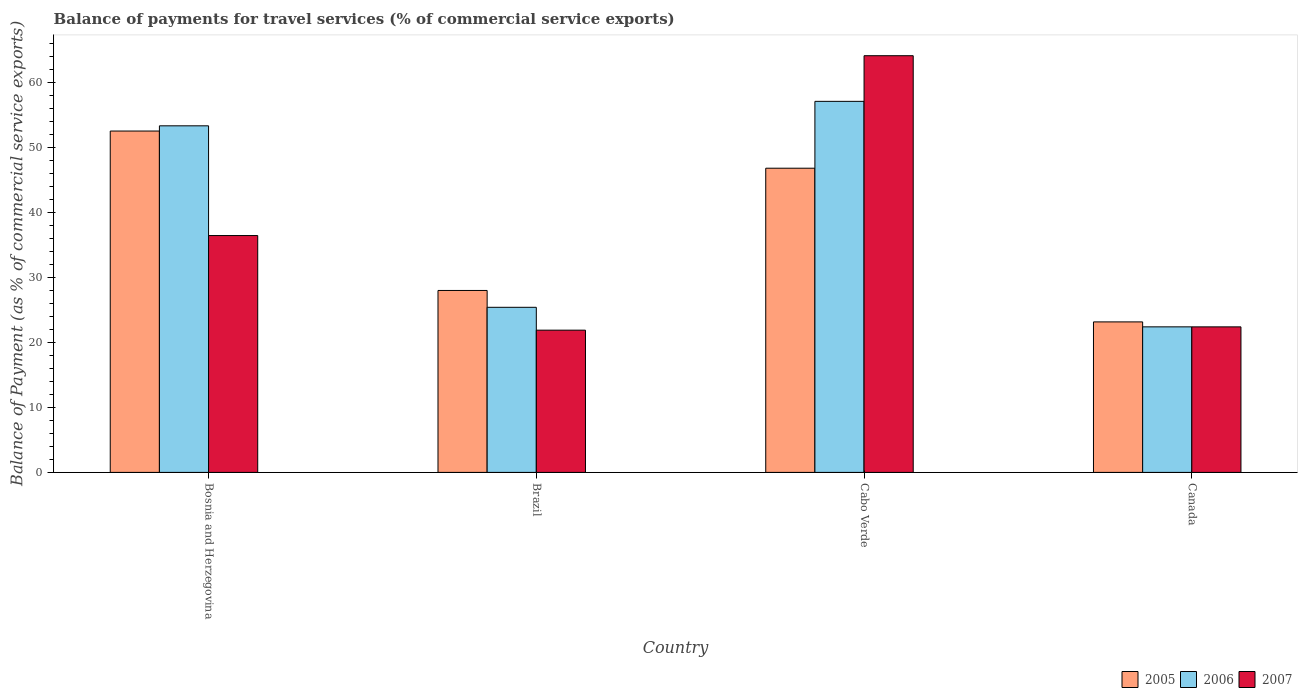How many groups of bars are there?
Offer a terse response. 4. Are the number of bars per tick equal to the number of legend labels?
Ensure brevity in your answer.  Yes. How many bars are there on the 1st tick from the left?
Keep it short and to the point. 3. What is the label of the 1st group of bars from the left?
Your answer should be compact. Bosnia and Herzegovina. In how many cases, is the number of bars for a given country not equal to the number of legend labels?
Ensure brevity in your answer.  0. What is the balance of payments for travel services in 2006 in Bosnia and Herzegovina?
Ensure brevity in your answer.  53.36. Across all countries, what is the maximum balance of payments for travel services in 2007?
Keep it short and to the point. 64.16. Across all countries, what is the minimum balance of payments for travel services in 2005?
Offer a very short reply. 23.17. In which country was the balance of payments for travel services in 2005 maximum?
Give a very brief answer. Bosnia and Herzegovina. What is the total balance of payments for travel services in 2007 in the graph?
Provide a short and direct response. 144.94. What is the difference between the balance of payments for travel services in 2007 in Cabo Verde and that in Canada?
Keep it short and to the point. 41.75. What is the difference between the balance of payments for travel services in 2007 in Bosnia and Herzegovina and the balance of payments for travel services in 2005 in Brazil?
Your answer should be compact. 8.45. What is the average balance of payments for travel services in 2007 per country?
Your answer should be very brief. 36.23. What is the difference between the balance of payments for travel services of/in 2006 and balance of payments for travel services of/in 2005 in Bosnia and Herzegovina?
Your answer should be compact. 0.8. What is the ratio of the balance of payments for travel services in 2006 in Cabo Verde to that in Canada?
Make the answer very short. 2.55. Is the difference between the balance of payments for travel services in 2006 in Bosnia and Herzegovina and Brazil greater than the difference between the balance of payments for travel services in 2005 in Bosnia and Herzegovina and Brazil?
Provide a short and direct response. Yes. What is the difference between the highest and the second highest balance of payments for travel services in 2005?
Keep it short and to the point. 24.55. What is the difference between the highest and the lowest balance of payments for travel services in 2005?
Provide a succinct answer. 29.39. Is the sum of the balance of payments for travel services in 2005 in Cabo Verde and Canada greater than the maximum balance of payments for travel services in 2006 across all countries?
Provide a succinct answer. Yes. What does the 1st bar from the left in Canada represents?
Provide a short and direct response. 2005. How many bars are there?
Your answer should be very brief. 12. Are all the bars in the graph horizontal?
Make the answer very short. No. What is the difference between two consecutive major ticks on the Y-axis?
Ensure brevity in your answer.  10. Does the graph contain grids?
Provide a short and direct response. No. How are the legend labels stacked?
Provide a short and direct response. Horizontal. What is the title of the graph?
Your response must be concise. Balance of payments for travel services (% of commercial service exports). Does "1990" appear as one of the legend labels in the graph?
Offer a terse response. No. What is the label or title of the X-axis?
Your answer should be compact. Country. What is the label or title of the Y-axis?
Provide a short and direct response. Balance of Payment (as % of commercial service exports). What is the Balance of Payment (as % of commercial service exports) in 2005 in Bosnia and Herzegovina?
Ensure brevity in your answer.  52.56. What is the Balance of Payment (as % of commercial service exports) of 2006 in Bosnia and Herzegovina?
Give a very brief answer. 53.36. What is the Balance of Payment (as % of commercial service exports) of 2007 in Bosnia and Herzegovina?
Provide a succinct answer. 36.47. What is the Balance of Payment (as % of commercial service exports) of 2005 in Brazil?
Your response must be concise. 28.01. What is the Balance of Payment (as % of commercial service exports) of 2006 in Brazil?
Your answer should be compact. 25.42. What is the Balance of Payment (as % of commercial service exports) in 2007 in Brazil?
Your answer should be compact. 21.9. What is the Balance of Payment (as % of commercial service exports) of 2005 in Cabo Verde?
Your answer should be very brief. 46.84. What is the Balance of Payment (as % of commercial service exports) in 2006 in Cabo Verde?
Ensure brevity in your answer.  57.13. What is the Balance of Payment (as % of commercial service exports) in 2007 in Cabo Verde?
Provide a succinct answer. 64.16. What is the Balance of Payment (as % of commercial service exports) in 2005 in Canada?
Make the answer very short. 23.17. What is the Balance of Payment (as % of commercial service exports) in 2006 in Canada?
Give a very brief answer. 22.41. What is the Balance of Payment (as % of commercial service exports) in 2007 in Canada?
Make the answer very short. 22.41. Across all countries, what is the maximum Balance of Payment (as % of commercial service exports) in 2005?
Make the answer very short. 52.56. Across all countries, what is the maximum Balance of Payment (as % of commercial service exports) in 2006?
Give a very brief answer. 57.13. Across all countries, what is the maximum Balance of Payment (as % of commercial service exports) in 2007?
Provide a succinct answer. 64.16. Across all countries, what is the minimum Balance of Payment (as % of commercial service exports) of 2005?
Offer a terse response. 23.17. Across all countries, what is the minimum Balance of Payment (as % of commercial service exports) in 2006?
Your answer should be compact. 22.41. Across all countries, what is the minimum Balance of Payment (as % of commercial service exports) in 2007?
Provide a succinct answer. 21.9. What is the total Balance of Payment (as % of commercial service exports) of 2005 in the graph?
Provide a succinct answer. 150.59. What is the total Balance of Payment (as % of commercial service exports) of 2006 in the graph?
Your answer should be very brief. 158.33. What is the total Balance of Payment (as % of commercial service exports) in 2007 in the graph?
Your answer should be very brief. 144.94. What is the difference between the Balance of Payment (as % of commercial service exports) in 2005 in Bosnia and Herzegovina and that in Brazil?
Make the answer very short. 24.55. What is the difference between the Balance of Payment (as % of commercial service exports) in 2006 in Bosnia and Herzegovina and that in Brazil?
Give a very brief answer. 27.94. What is the difference between the Balance of Payment (as % of commercial service exports) in 2007 in Bosnia and Herzegovina and that in Brazil?
Give a very brief answer. 14.57. What is the difference between the Balance of Payment (as % of commercial service exports) of 2005 in Bosnia and Herzegovina and that in Cabo Verde?
Make the answer very short. 5.72. What is the difference between the Balance of Payment (as % of commercial service exports) in 2006 in Bosnia and Herzegovina and that in Cabo Verde?
Provide a short and direct response. -3.77. What is the difference between the Balance of Payment (as % of commercial service exports) of 2007 in Bosnia and Herzegovina and that in Cabo Verde?
Ensure brevity in your answer.  -27.69. What is the difference between the Balance of Payment (as % of commercial service exports) of 2005 in Bosnia and Herzegovina and that in Canada?
Provide a short and direct response. 29.39. What is the difference between the Balance of Payment (as % of commercial service exports) of 2006 in Bosnia and Herzegovina and that in Canada?
Offer a terse response. 30.95. What is the difference between the Balance of Payment (as % of commercial service exports) of 2007 in Bosnia and Herzegovina and that in Canada?
Offer a very short reply. 14.06. What is the difference between the Balance of Payment (as % of commercial service exports) in 2005 in Brazil and that in Cabo Verde?
Make the answer very short. -18.82. What is the difference between the Balance of Payment (as % of commercial service exports) in 2006 in Brazil and that in Cabo Verde?
Give a very brief answer. -31.71. What is the difference between the Balance of Payment (as % of commercial service exports) in 2007 in Brazil and that in Cabo Verde?
Provide a succinct answer. -42.26. What is the difference between the Balance of Payment (as % of commercial service exports) of 2005 in Brazil and that in Canada?
Your answer should be very brief. 4.84. What is the difference between the Balance of Payment (as % of commercial service exports) of 2006 in Brazil and that in Canada?
Your answer should be very brief. 3.01. What is the difference between the Balance of Payment (as % of commercial service exports) in 2007 in Brazil and that in Canada?
Keep it short and to the point. -0.51. What is the difference between the Balance of Payment (as % of commercial service exports) in 2005 in Cabo Verde and that in Canada?
Keep it short and to the point. 23.66. What is the difference between the Balance of Payment (as % of commercial service exports) in 2006 in Cabo Verde and that in Canada?
Keep it short and to the point. 34.72. What is the difference between the Balance of Payment (as % of commercial service exports) of 2007 in Cabo Verde and that in Canada?
Provide a short and direct response. 41.75. What is the difference between the Balance of Payment (as % of commercial service exports) of 2005 in Bosnia and Herzegovina and the Balance of Payment (as % of commercial service exports) of 2006 in Brazil?
Provide a short and direct response. 27.14. What is the difference between the Balance of Payment (as % of commercial service exports) of 2005 in Bosnia and Herzegovina and the Balance of Payment (as % of commercial service exports) of 2007 in Brazil?
Offer a terse response. 30.66. What is the difference between the Balance of Payment (as % of commercial service exports) in 2006 in Bosnia and Herzegovina and the Balance of Payment (as % of commercial service exports) in 2007 in Brazil?
Give a very brief answer. 31.46. What is the difference between the Balance of Payment (as % of commercial service exports) in 2005 in Bosnia and Herzegovina and the Balance of Payment (as % of commercial service exports) in 2006 in Cabo Verde?
Give a very brief answer. -4.57. What is the difference between the Balance of Payment (as % of commercial service exports) in 2005 in Bosnia and Herzegovina and the Balance of Payment (as % of commercial service exports) in 2007 in Cabo Verde?
Give a very brief answer. -11.6. What is the difference between the Balance of Payment (as % of commercial service exports) of 2006 in Bosnia and Herzegovina and the Balance of Payment (as % of commercial service exports) of 2007 in Cabo Verde?
Ensure brevity in your answer.  -10.8. What is the difference between the Balance of Payment (as % of commercial service exports) of 2005 in Bosnia and Herzegovina and the Balance of Payment (as % of commercial service exports) of 2006 in Canada?
Keep it short and to the point. 30.15. What is the difference between the Balance of Payment (as % of commercial service exports) in 2005 in Bosnia and Herzegovina and the Balance of Payment (as % of commercial service exports) in 2007 in Canada?
Offer a terse response. 30.15. What is the difference between the Balance of Payment (as % of commercial service exports) of 2006 in Bosnia and Herzegovina and the Balance of Payment (as % of commercial service exports) of 2007 in Canada?
Provide a succinct answer. 30.96. What is the difference between the Balance of Payment (as % of commercial service exports) in 2005 in Brazil and the Balance of Payment (as % of commercial service exports) in 2006 in Cabo Verde?
Offer a terse response. -29.12. What is the difference between the Balance of Payment (as % of commercial service exports) in 2005 in Brazil and the Balance of Payment (as % of commercial service exports) in 2007 in Cabo Verde?
Your answer should be very brief. -36.15. What is the difference between the Balance of Payment (as % of commercial service exports) in 2006 in Brazil and the Balance of Payment (as % of commercial service exports) in 2007 in Cabo Verde?
Your answer should be very brief. -38.74. What is the difference between the Balance of Payment (as % of commercial service exports) in 2005 in Brazil and the Balance of Payment (as % of commercial service exports) in 2006 in Canada?
Give a very brief answer. 5.6. What is the difference between the Balance of Payment (as % of commercial service exports) of 2005 in Brazil and the Balance of Payment (as % of commercial service exports) of 2007 in Canada?
Your answer should be very brief. 5.61. What is the difference between the Balance of Payment (as % of commercial service exports) in 2006 in Brazil and the Balance of Payment (as % of commercial service exports) in 2007 in Canada?
Your answer should be compact. 3.01. What is the difference between the Balance of Payment (as % of commercial service exports) in 2005 in Cabo Verde and the Balance of Payment (as % of commercial service exports) in 2006 in Canada?
Offer a very short reply. 24.43. What is the difference between the Balance of Payment (as % of commercial service exports) in 2005 in Cabo Verde and the Balance of Payment (as % of commercial service exports) in 2007 in Canada?
Give a very brief answer. 24.43. What is the difference between the Balance of Payment (as % of commercial service exports) in 2006 in Cabo Verde and the Balance of Payment (as % of commercial service exports) in 2007 in Canada?
Offer a terse response. 34.72. What is the average Balance of Payment (as % of commercial service exports) in 2005 per country?
Provide a short and direct response. 37.65. What is the average Balance of Payment (as % of commercial service exports) of 2006 per country?
Give a very brief answer. 39.58. What is the average Balance of Payment (as % of commercial service exports) of 2007 per country?
Provide a succinct answer. 36.23. What is the difference between the Balance of Payment (as % of commercial service exports) in 2005 and Balance of Payment (as % of commercial service exports) in 2006 in Bosnia and Herzegovina?
Provide a short and direct response. -0.8. What is the difference between the Balance of Payment (as % of commercial service exports) in 2005 and Balance of Payment (as % of commercial service exports) in 2007 in Bosnia and Herzegovina?
Your response must be concise. 16.09. What is the difference between the Balance of Payment (as % of commercial service exports) in 2006 and Balance of Payment (as % of commercial service exports) in 2007 in Bosnia and Herzegovina?
Give a very brief answer. 16.9. What is the difference between the Balance of Payment (as % of commercial service exports) in 2005 and Balance of Payment (as % of commercial service exports) in 2006 in Brazil?
Give a very brief answer. 2.59. What is the difference between the Balance of Payment (as % of commercial service exports) in 2005 and Balance of Payment (as % of commercial service exports) in 2007 in Brazil?
Offer a very short reply. 6.11. What is the difference between the Balance of Payment (as % of commercial service exports) in 2006 and Balance of Payment (as % of commercial service exports) in 2007 in Brazil?
Make the answer very short. 3.52. What is the difference between the Balance of Payment (as % of commercial service exports) of 2005 and Balance of Payment (as % of commercial service exports) of 2006 in Cabo Verde?
Keep it short and to the point. -10.29. What is the difference between the Balance of Payment (as % of commercial service exports) of 2005 and Balance of Payment (as % of commercial service exports) of 2007 in Cabo Verde?
Your answer should be compact. -17.32. What is the difference between the Balance of Payment (as % of commercial service exports) of 2006 and Balance of Payment (as % of commercial service exports) of 2007 in Cabo Verde?
Provide a succinct answer. -7.03. What is the difference between the Balance of Payment (as % of commercial service exports) of 2005 and Balance of Payment (as % of commercial service exports) of 2006 in Canada?
Your response must be concise. 0.76. What is the difference between the Balance of Payment (as % of commercial service exports) in 2005 and Balance of Payment (as % of commercial service exports) in 2007 in Canada?
Make the answer very short. 0.77. What is the difference between the Balance of Payment (as % of commercial service exports) of 2006 and Balance of Payment (as % of commercial service exports) of 2007 in Canada?
Offer a terse response. 0. What is the ratio of the Balance of Payment (as % of commercial service exports) of 2005 in Bosnia and Herzegovina to that in Brazil?
Give a very brief answer. 1.88. What is the ratio of the Balance of Payment (as % of commercial service exports) in 2006 in Bosnia and Herzegovina to that in Brazil?
Give a very brief answer. 2.1. What is the ratio of the Balance of Payment (as % of commercial service exports) of 2007 in Bosnia and Herzegovina to that in Brazil?
Provide a succinct answer. 1.67. What is the ratio of the Balance of Payment (as % of commercial service exports) in 2005 in Bosnia and Herzegovina to that in Cabo Verde?
Your answer should be very brief. 1.12. What is the ratio of the Balance of Payment (as % of commercial service exports) of 2006 in Bosnia and Herzegovina to that in Cabo Verde?
Ensure brevity in your answer.  0.93. What is the ratio of the Balance of Payment (as % of commercial service exports) in 2007 in Bosnia and Herzegovina to that in Cabo Verde?
Keep it short and to the point. 0.57. What is the ratio of the Balance of Payment (as % of commercial service exports) in 2005 in Bosnia and Herzegovina to that in Canada?
Offer a very short reply. 2.27. What is the ratio of the Balance of Payment (as % of commercial service exports) in 2006 in Bosnia and Herzegovina to that in Canada?
Provide a succinct answer. 2.38. What is the ratio of the Balance of Payment (as % of commercial service exports) of 2007 in Bosnia and Herzegovina to that in Canada?
Your response must be concise. 1.63. What is the ratio of the Balance of Payment (as % of commercial service exports) in 2005 in Brazil to that in Cabo Verde?
Provide a succinct answer. 0.6. What is the ratio of the Balance of Payment (as % of commercial service exports) in 2006 in Brazil to that in Cabo Verde?
Give a very brief answer. 0.44. What is the ratio of the Balance of Payment (as % of commercial service exports) in 2007 in Brazil to that in Cabo Verde?
Your answer should be compact. 0.34. What is the ratio of the Balance of Payment (as % of commercial service exports) in 2005 in Brazil to that in Canada?
Ensure brevity in your answer.  1.21. What is the ratio of the Balance of Payment (as % of commercial service exports) in 2006 in Brazil to that in Canada?
Your response must be concise. 1.13. What is the ratio of the Balance of Payment (as % of commercial service exports) in 2007 in Brazil to that in Canada?
Offer a very short reply. 0.98. What is the ratio of the Balance of Payment (as % of commercial service exports) in 2005 in Cabo Verde to that in Canada?
Keep it short and to the point. 2.02. What is the ratio of the Balance of Payment (as % of commercial service exports) of 2006 in Cabo Verde to that in Canada?
Provide a short and direct response. 2.55. What is the ratio of the Balance of Payment (as % of commercial service exports) in 2007 in Cabo Verde to that in Canada?
Keep it short and to the point. 2.86. What is the difference between the highest and the second highest Balance of Payment (as % of commercial service exports) of 2005?
Give a very brief answer. 5.72. What is the difference between the highest and the second highest Balance of Payment (as % of commercial service exports) of 2006?
Give a very brief answer. 3.77. What is the difference between the highest and the second highest Balance of Payment (as % of commercial service exports) of 2007?
Provide a short and direct response. 27.69. What is the difference between the highest and the lowest Balance of Payment (as % of commercial service exports) of 2005?
Offer a very short reply. 29.39. What is the difference between the highest and the lowest Balance of Payment (as % of commercial service exports) of 2006?
Your answer should be compact. 34.72. What is the difference between the highest and the lowest Balance of Payment (as % of commercial service exports) in 2007?
Offer a terse response. 42.26. 